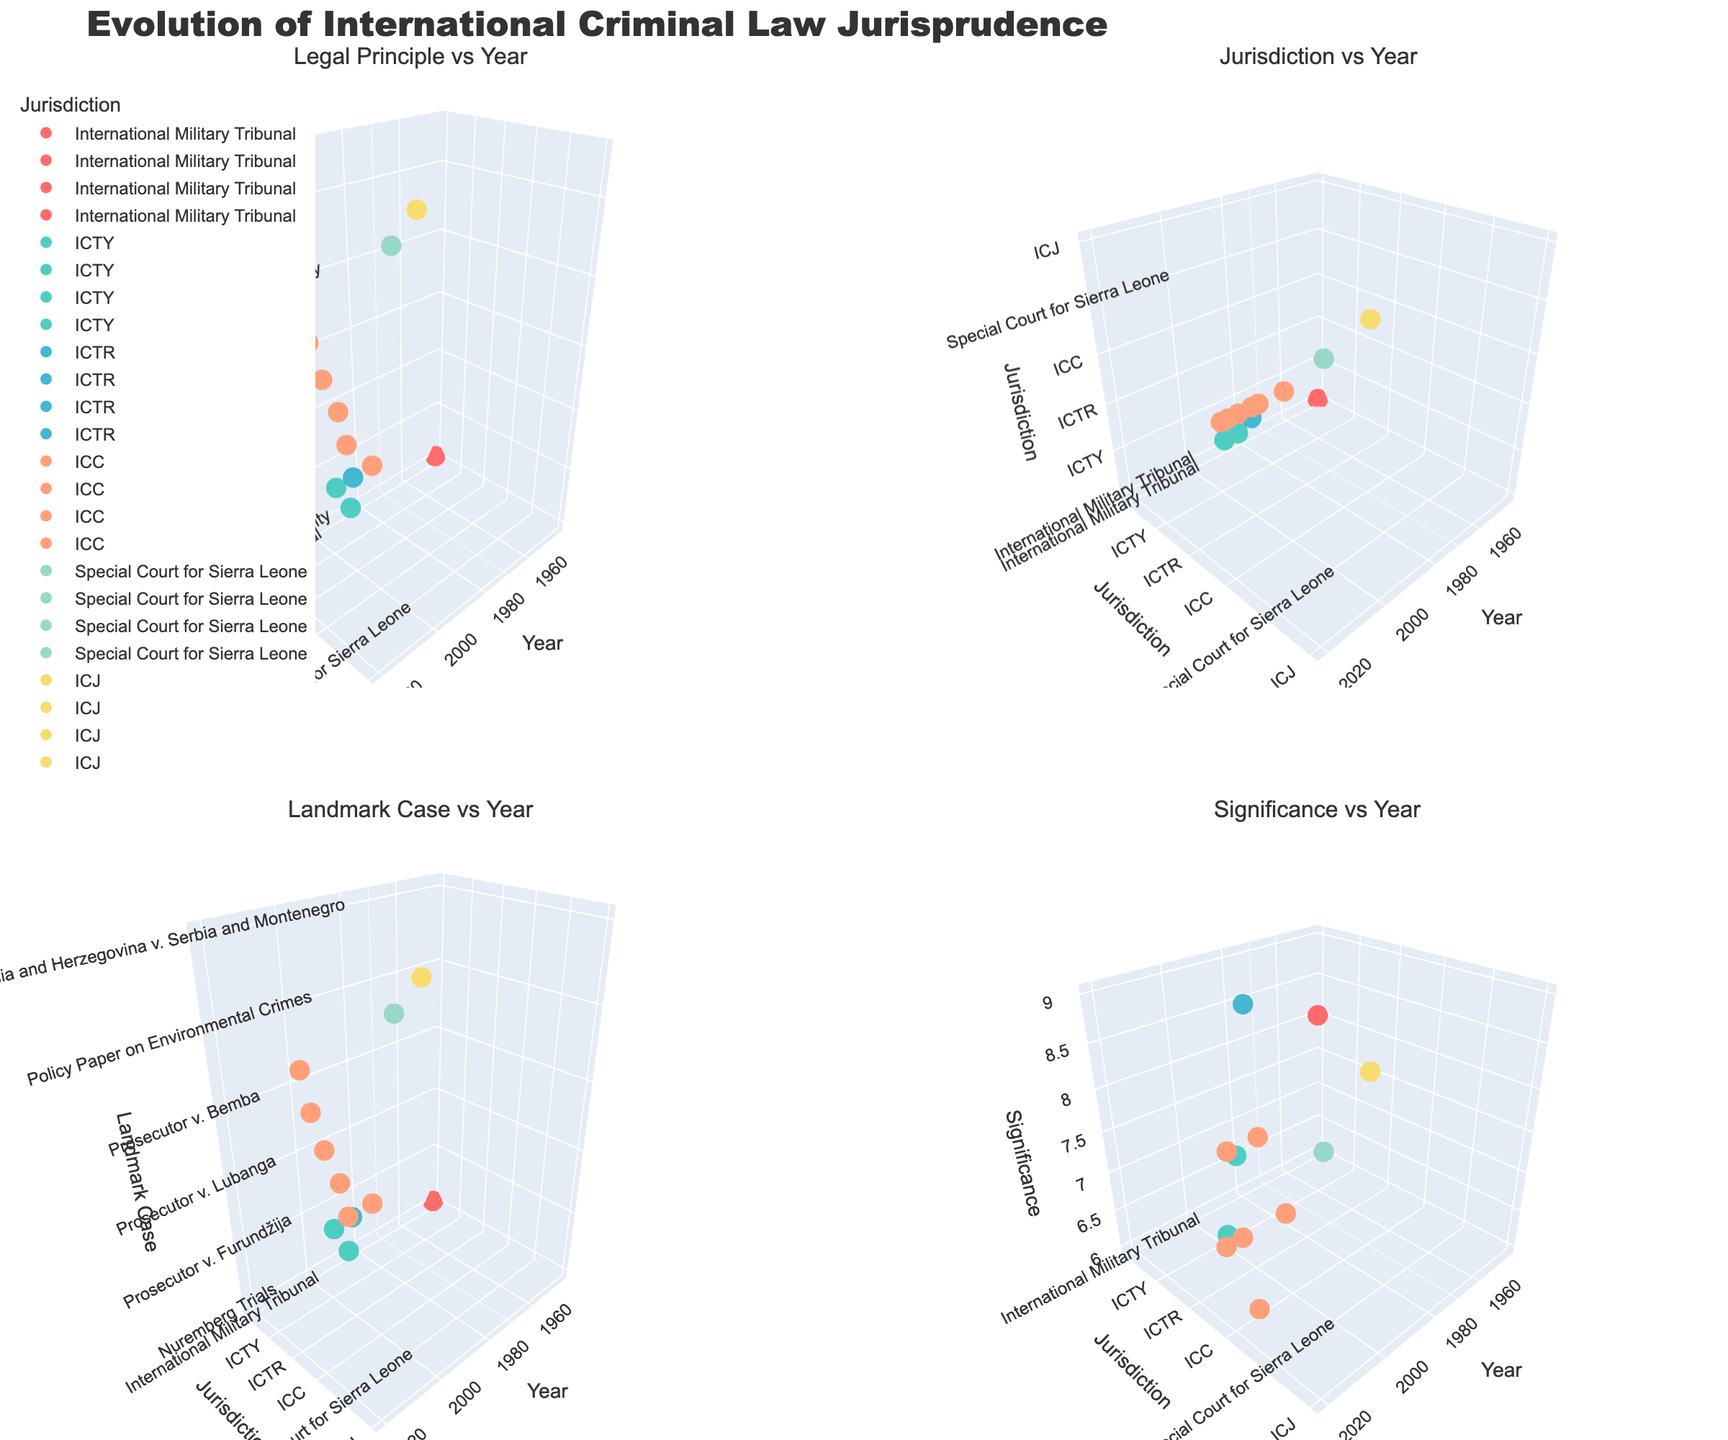What is the title of the figure? The title of the figure is always displayed at the top of the plot. From the instructions, the title is mentioned explicitly.
Answer: Evolution of International Criminal Law Jurisprudence How many subplots are there in the figure? The layout section of the plot specifies that there are four subplots, arranged in a 2x2 grid, indicated by the 'subplot_titles' parameter with four titles.
Answer: 4 Which subplot corresponds to the "Jurisdiction vs Year" plot? In the subplot titles provided in the code, "Jurisdiction vs Year" is listed as the second subplot. This means it is located in the first row, second column.
Answer: First row, second column What colors are used to represent the different jurisdictions in the figure? The colors used for the jurisdictions are listed in the code as hex values corresponding to specific color names. These are #FF6B6B, #4ECDC4, #45B7D1, #FFA07A, #98D8C8, and #F7DC6F.
Answer: Red, Teal, Light Blue, Light Salmon, Light Green, Light Yellow Which jurisdiction has the earliest data point and in which year? By examining the x-axis (years) and the y-axis (jurisdictions), we can determine the earliest point by observing the leftmost marker. The earliest year noted is 1945 for the International Military Tribunal jurisdiction.
Answer: International Military Tribunal, 1945 From which year does the "Complementarity" legal principle appear in the data? By observing the "Legal Principle vs Year" subplot and locating the point for "Complementarity" on the z-axis, we can determine its corresponding x-axis (year).
Answer: 2002 Which landmark case has the highest significance rating, and what is that rating? The "Significance vs Year" subplot shows the z-axis representing significance ratings. The highest z-value should be checked, and the corresponding y (jurisdiction) and legend should guide us to the case. "Prosecutor v. Akayesu" reaches a maximum significance of 9.
Answer: Prosecutor v. Akayesu, 9 Between 2000 and 2010, how many unique legal principles were established? Examining the "Legal Principle vs Year" subplot between the years 2000 and 2010, count the unique markers on the z-axis and their corresponding legal principles. In this range, there are "Sexual Violence as War Crime," "Complementarity," "Head of State Immunity," and "Recruitment of Child Soldiers."
Answer: 4 Which jurisdiction shows up most frequently across all subplots? By examining the number of markers related to each jurisdiction in all subplots, the jurisdiction that appears most often can be counted. The ICC (International Criminal Court) appears most frequently.
Answer: ICC Who is the landmark case "Prosecutor v. Charles Taylor" associated with, and in which category it is plotted? By examining the "Landmark Case vs Year" subplot, locate "Prosecutor v. Charles Taylor" on the z-axis and trace the corresponding y-axis and subplot title legend. It appears for the Special Court for Sierra Leone, categorized under "Head of State Immunity."
Answer: Special Court for Sierra Leone, "Head of State Immunity" 